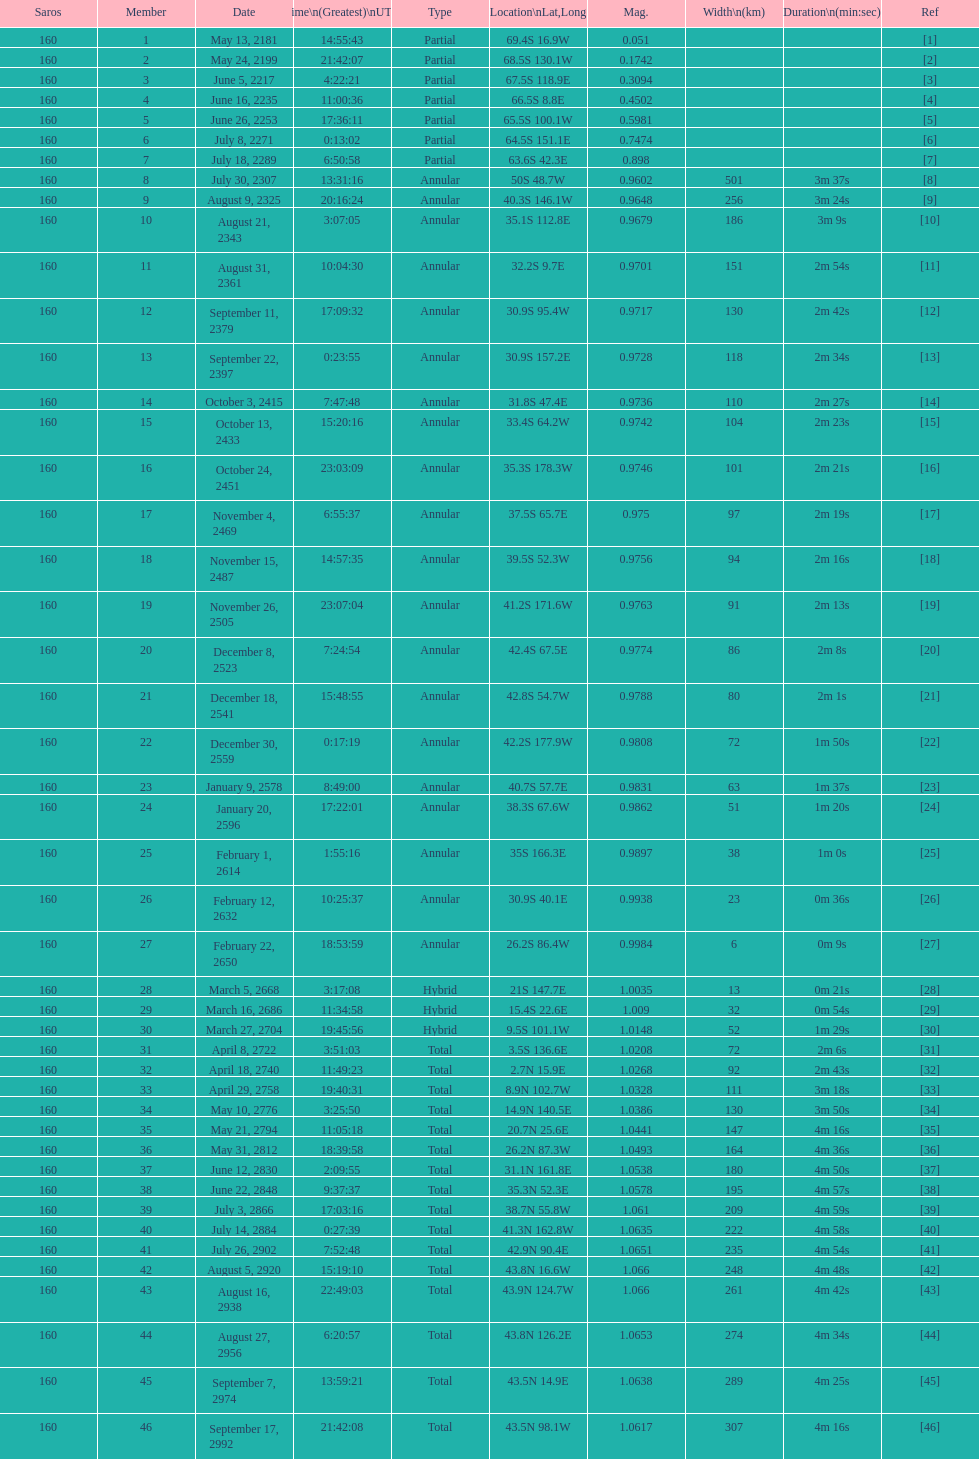How many total events will occur in all? 46. 